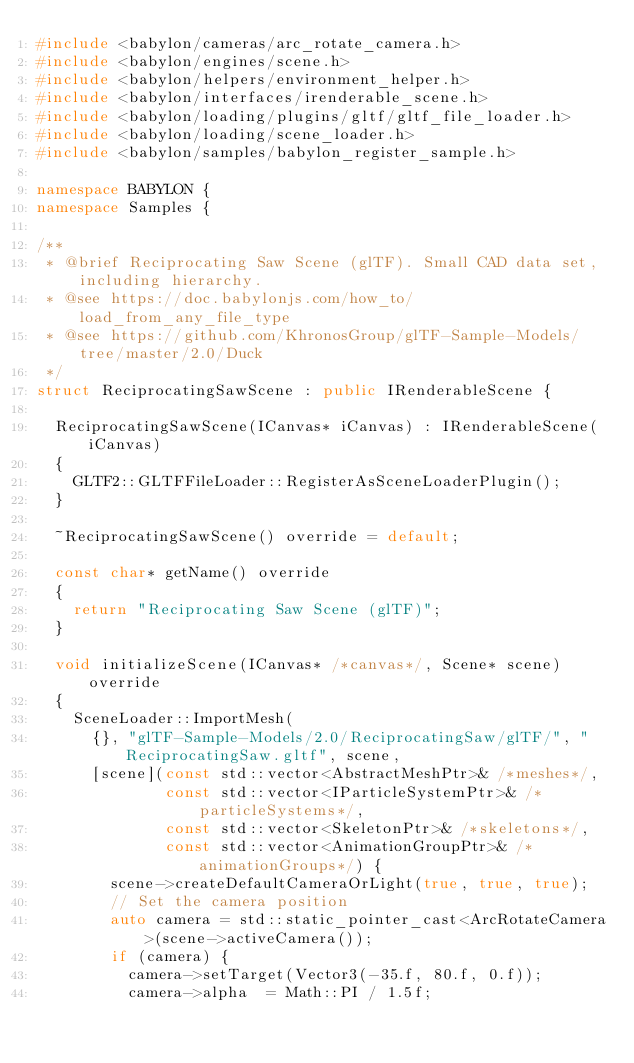<code> <loc_0><loc_0><loc_500><loc_500><_C++_>#include <babylon/cameras/arc_rotate_camera.h>
#include <babylon/engines/scene.h>
#include <babylon/helpers/environment_helper.h>
#include <babylon/interfaces/irenderable_scene.h>
#include <babylon/loading/plugins/gltf/gltf_file_loader.h>
#include <babylon/loading/scene_loader.h>
#include <babylon/samples/babylon_register_sample.h>

namespace BABYLON {
namespace Samples {

/**
 * @brief Reciprocating Saw Scene (glTF). Small CAD data set, including hierarchy.
 * @see https://doc.babylonjs.com/how_to/load_from_any_file_type
 * @see https://github.com/KhronosGroup/glTF-Sample-Models/tree/master/2.0/Duck
 */
struct ReciprocatingSawScene : public IRenderableScene {

  ReciprocatingSawScene(ICanvas* iCanvas) : IRenderableScene(iCanvas)
  {
    GLTF2::GLTFFileLoader::RegisterAsSceneLoaderPlugin();
  }

  ~ReciprocatingSawScene() override = default;

  const char* getName() override
  {
    return "Reciprocating Saw Scene (glTF)";
  }

  void initializeScene(ICanvas* /*canvas*/, Scene* scene) override
  {
    SceneLoader::ImportMesh(
      {}, "glTF-Sample-Models/2.0/ReciprocatingSaw/glTF/", "ReciprocatingSaw.gltf", scene,
      [scene](const std::vector<AbstractMeshPtr>& /*meshes*/,
              const std::vector<IParticleSystemPtr>& /*particleSystems*/,
              const std::vector<SkeletonPtr>& /*skeletons*/,
              const std::vector<AnimationGroupPtr>& /*animationGroups*/) {
        scene->createDefaultCameraOrLight(true, true, true);
        // Set the camera position
        auto camera = std::static_pointer_cast<ArcRotateCamera>(scene->activeCamera());
        if (camera) {
          camera->setTarget(Vector3(-35.f, 80.f, 0.f));
          camera->alpha  = Math::PI / 1.5f;</code> 